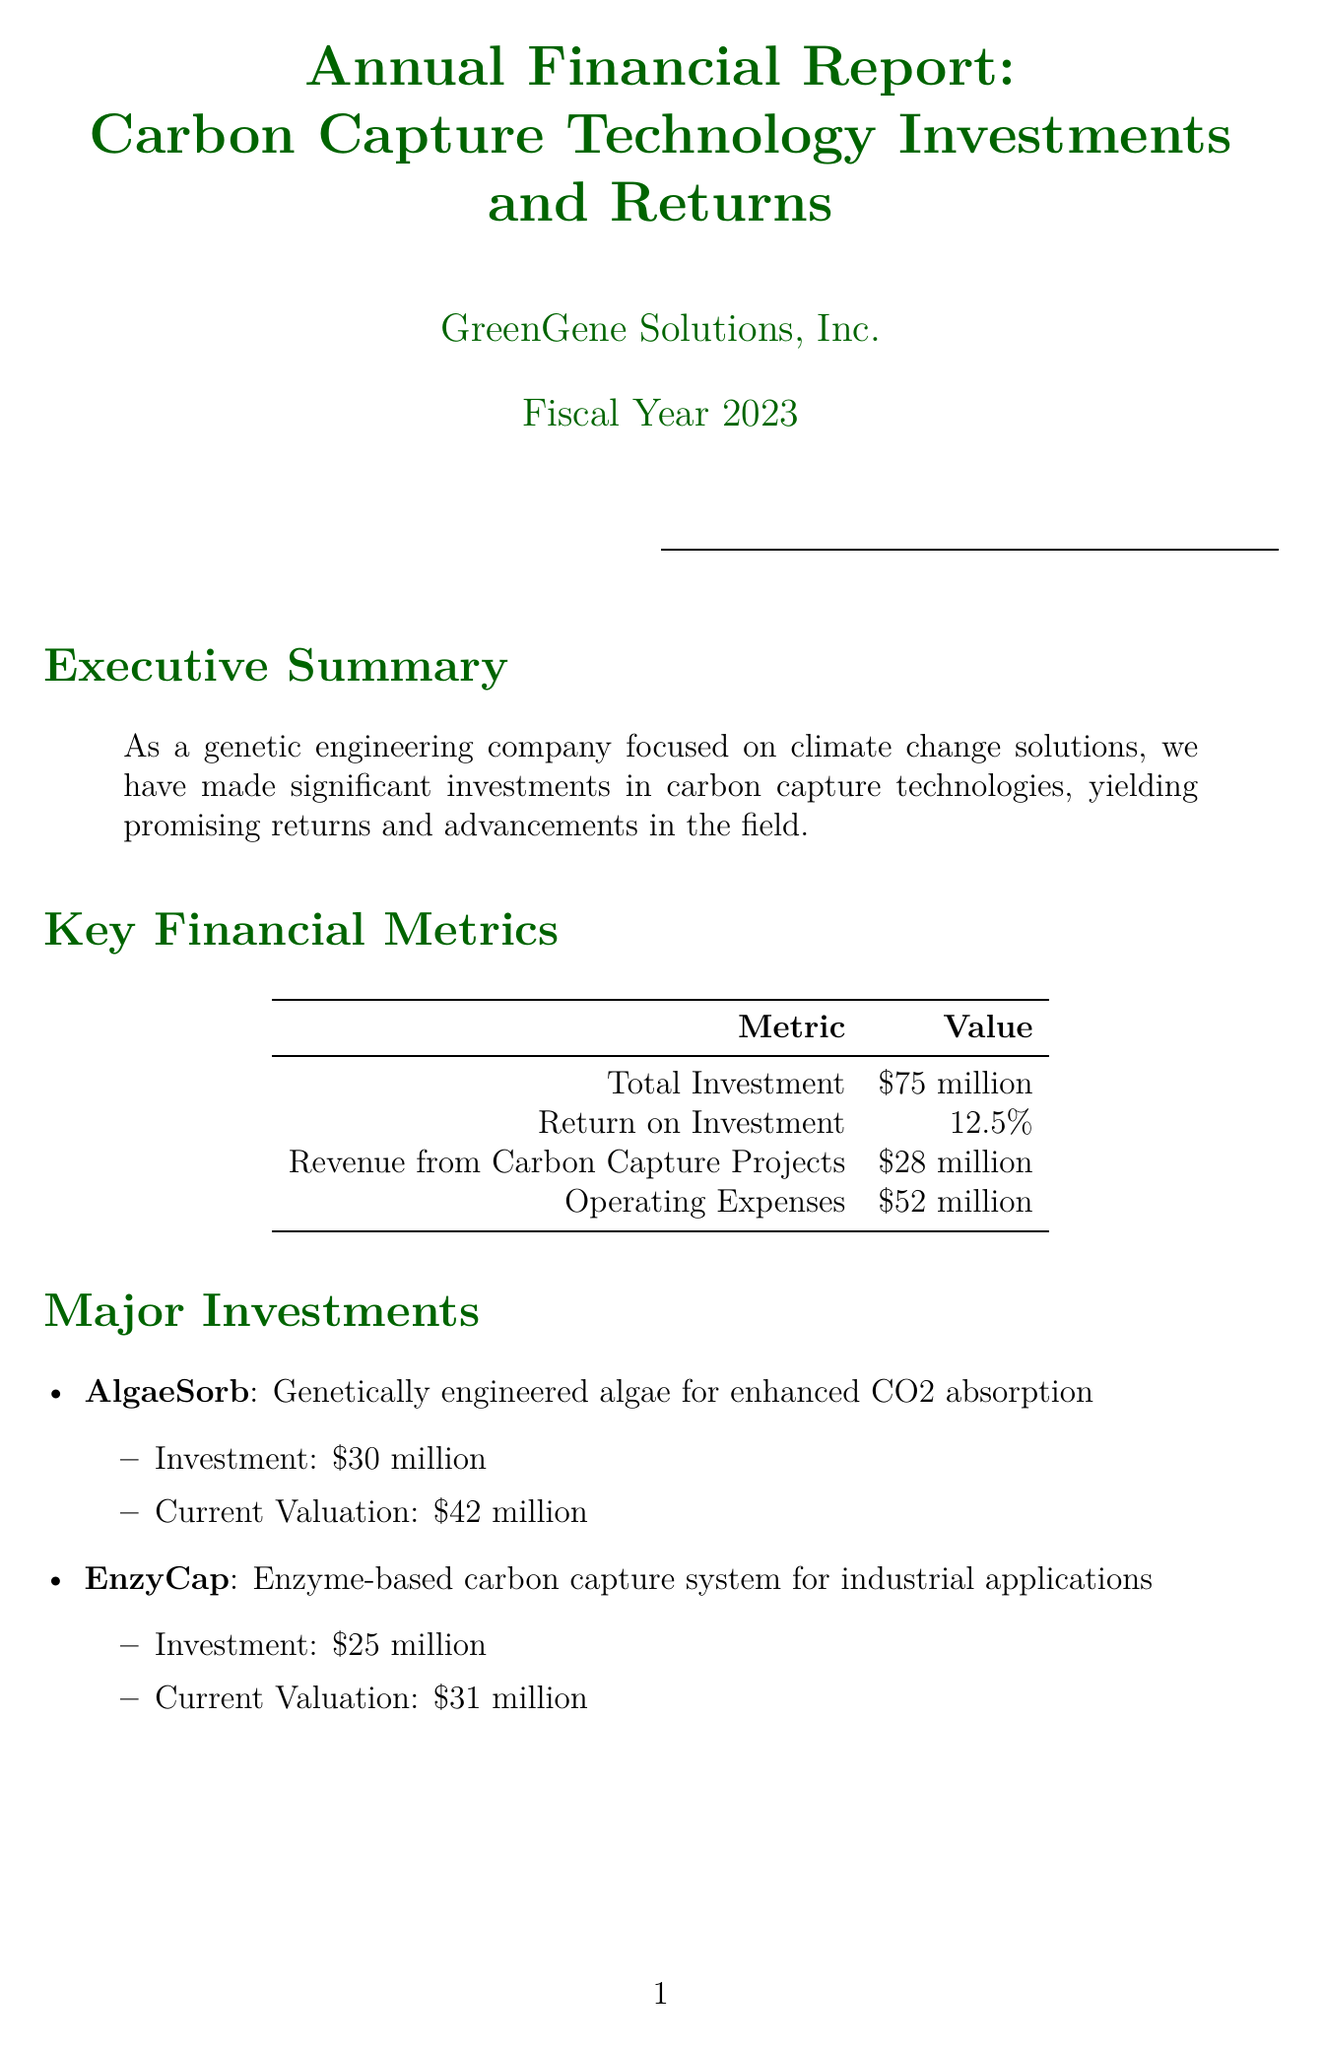what is the total investment? The total investment amount stated in the document is $75 million.
Answer: $75 million what is the return on investment? The document specifies the return on investment as 12.5%.
Answer: 12.5% which project received a $30 million investment? According to the document, the "AlgaeSorb" project received a $30 million investment.
Answer: AlgaeSorb how much revenue was generated from carbon capture projects? The revenue from carbon capture projects as mentioned in the report is $28 million.
Answer: $28 million what is the current valuation of the EnzyCap project? The current valuation of the EnzyCap project is listed as $31 million in the report.
Answer: $31 million what is the total R&D spending? The total research and development spending is noted as $20 million in the document.
Answer: $20 million who is the partner focusing on AlgaeSorb technology? The partner focusing on the AlgaeSorb technology is the "Global Climate Solutions Fund" as mentioned in the document.
Answer: Global Climate Solutions Fund what is the expected ROI for 2024? The expected return on investment for 2024 is projected to be 15% according to the future outlook section of the report.
Answer: 15% which key initiative involves gene-edited crops? The document states that the development of gene-edited crops for enhanced carbon sequestration in agriculture is a key initiative.
Answer: Development of gene-edited crops for enhanced carbon sequestration in agriculture 